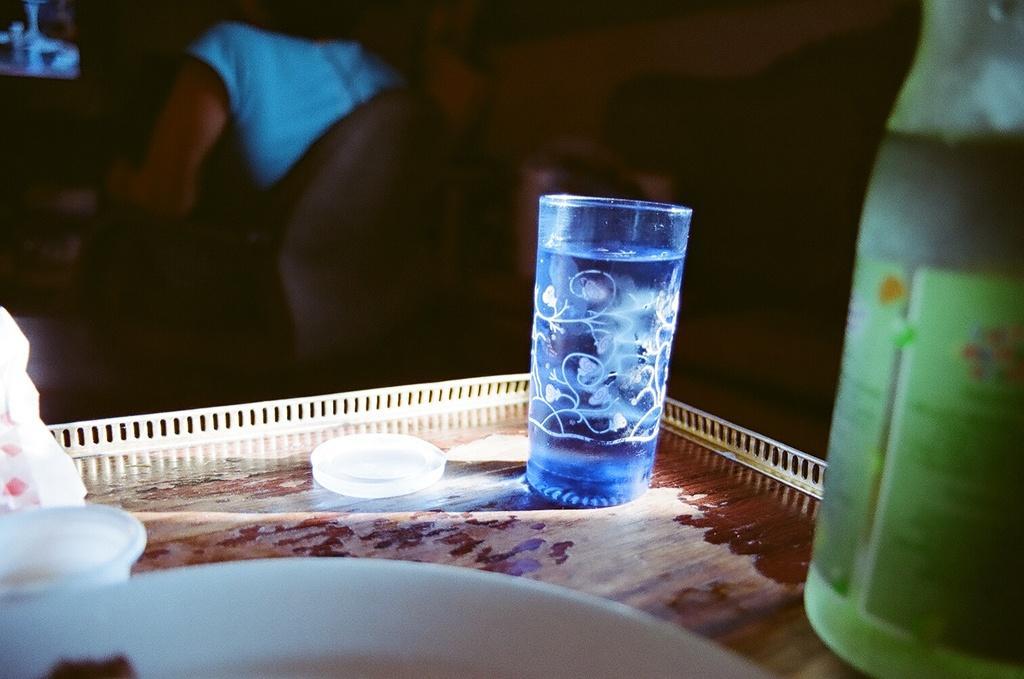How would you summarize this image in a sentence or two? In the image we can see there is a tray on which there is a glass and a wine bottle. 